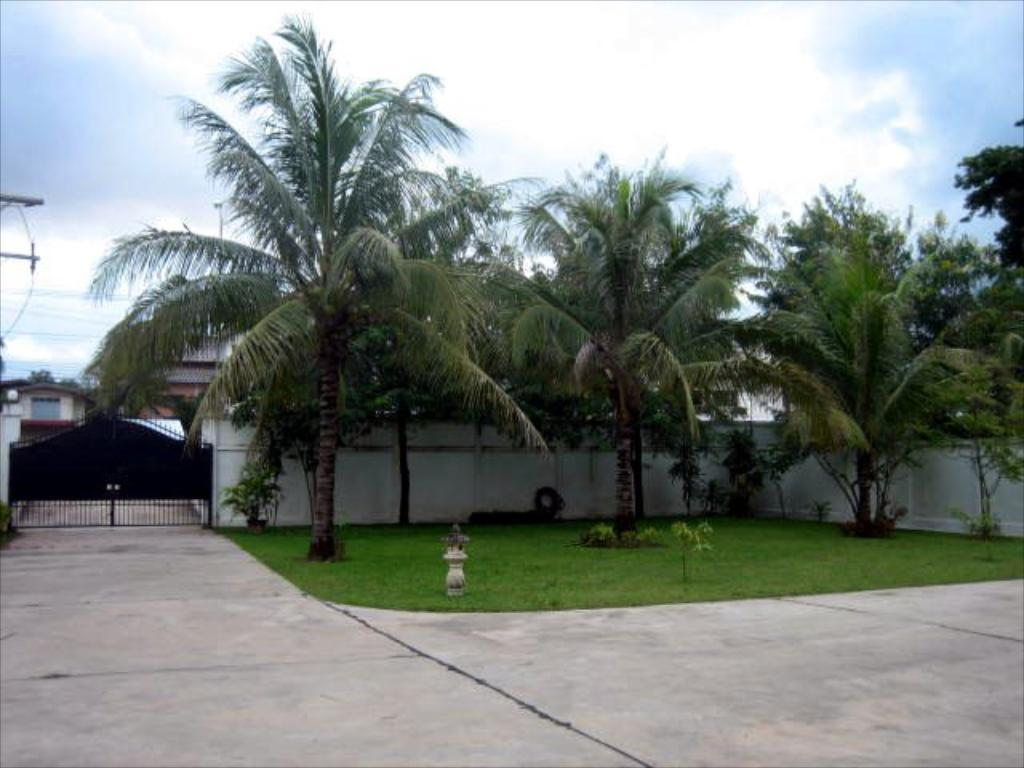What structure can be seen in the image? There is a gate in the image. What type of vegetation is present in the image? There are trees and plants in the image. What covers the ground in the image? There is grass on the floor in the image. What can be seen beyond the gate in the image? There are houses visible on the other side of the gate in the image. What type of disease is affecting the plants in the image? There is no indication of any disease affecting the plants in the image. What liquid can be seen flowing through the gate in the image? There is no liquid flowing through the gate in the image. 